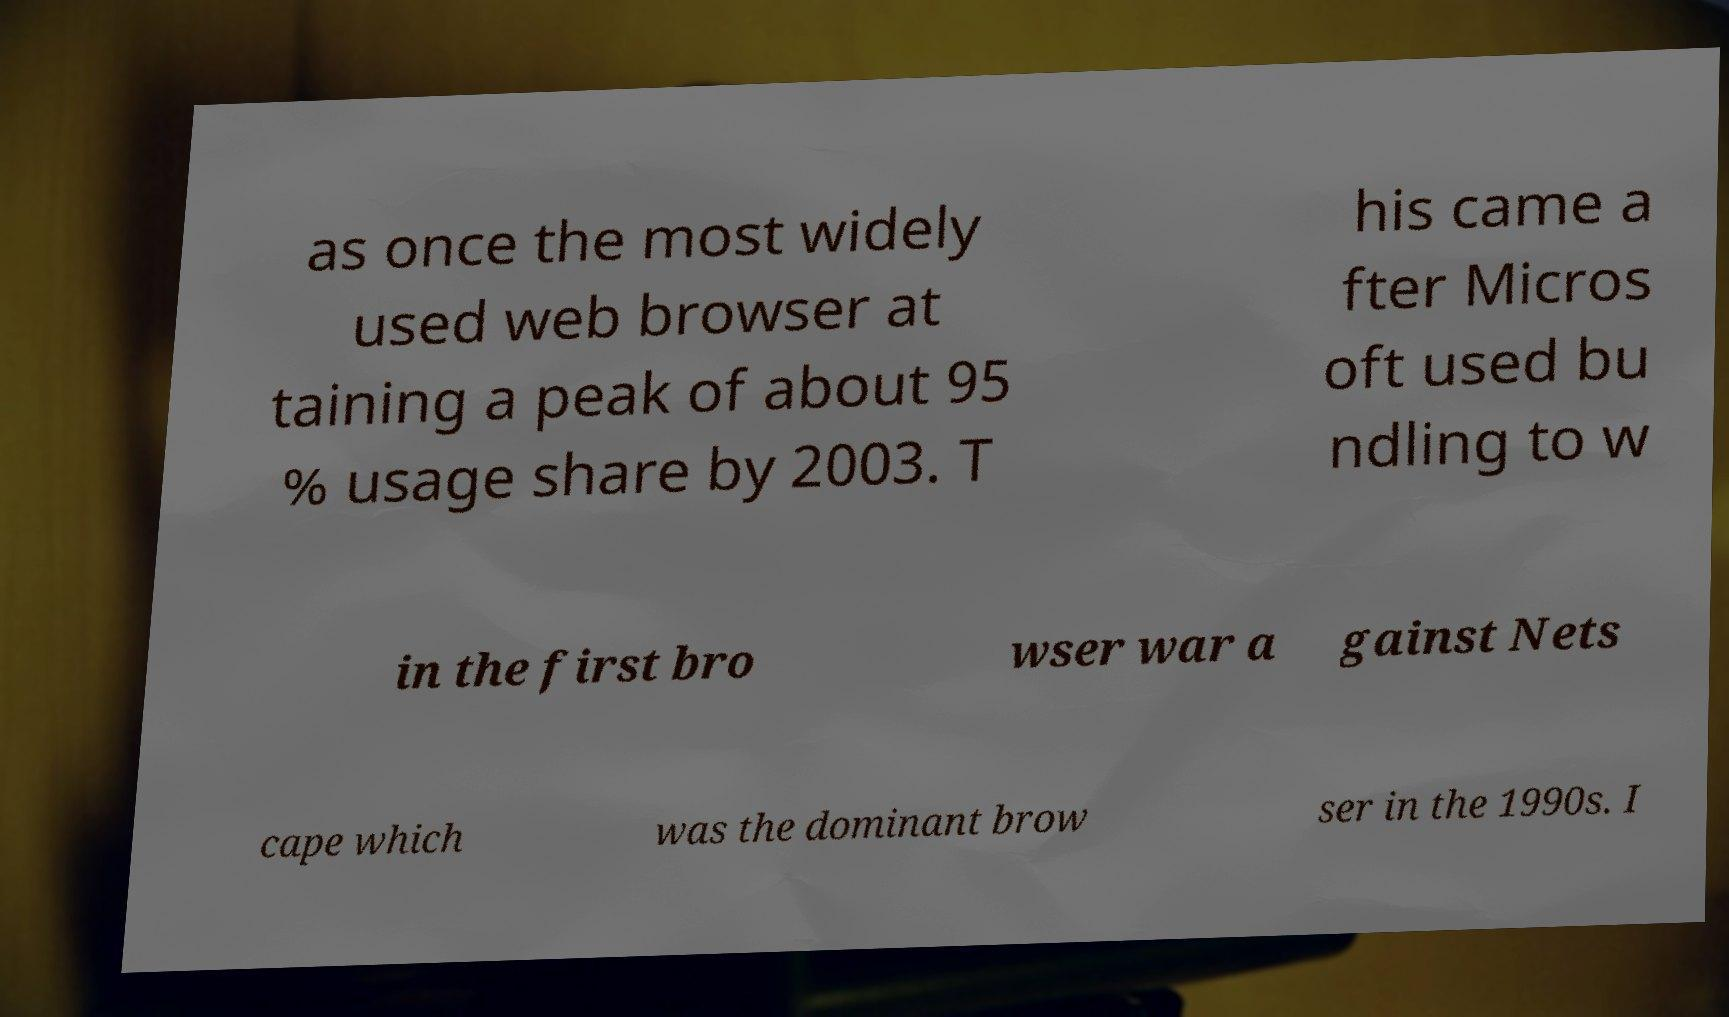Could you extract and type out the text from this image? as once the most widely used web browser at taining a peak of about 95 % usage share by 2003. T his came a fter Micros oft used bu ndling to w in the first bro wser war a gainst Nets cape which was the dominant brow ser in the 1990s. I 